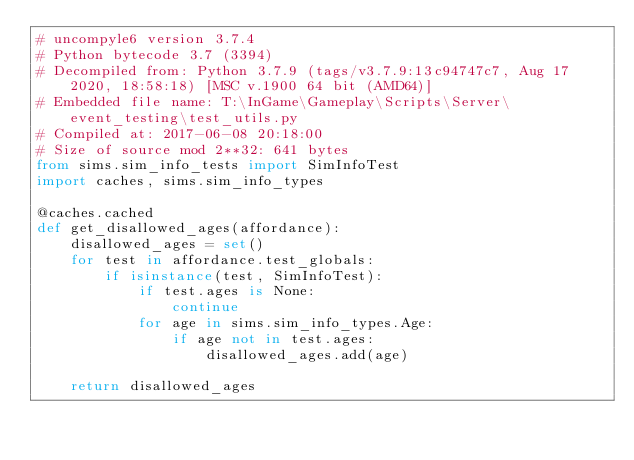Convert code to text. <code><loc_0><loc_0><loc_500><loc_500><_Python_># uncompyle6 version 3.7.4
# Python bytecode 3.7 (3394)
# Decompiled from: Python 3.7.9 (tags/v3.7.9:13c94747c7, Aug 17 2020, 18:58:18) [MSC v.1900 64 bit (AMD64)]
# Embedded file name: T:\InGame\Gameplay\Scripts\Server\event_testing\test_utils.py
# Compiled at: 2017-06-08 20:18:00
# Size of source mod 2**32: 641 bytes
from sims.sim_info_tests import SimInfoTest
import caches, sims.sim_info_types

@caches.cached
def get_disallowed_ages(affordance):
    disallowed_ages = set()
    for test in affordance.test_globals:
        if isinstance(test, SimInfoTest):
            if test.ages is None:
                continue
            for age in sims.sim_info_types.Age:
                if age not in test.ages:
                    disallowed_ages.add(age)

    return disallowed_ages</code> 